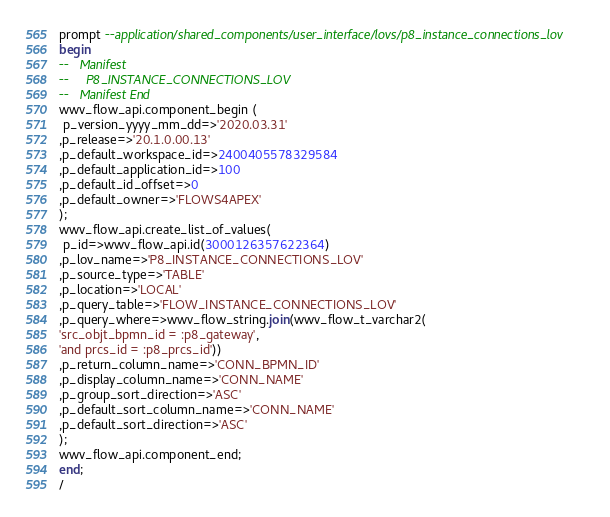<code> <loc_0><loc_0><loc_500><loc_500><_SQL_>prompt --application/shared_components/user_interface/lovs/p8_instance_connections_lov
begin
--   Manifest
--     P8_INSTANCE_CONNECTIONS_LOV
--   Manifest End
wwv_flow_api.component_begin (
 p_version_yyyy_mm_dd=>'2020.03.31'
,p_release=>'20.1.0.00.13'
,p_default_workspace_id=>2400405578329584
,p_default_application_id=>100
,p_default_id_offset=>0
,p_default_owner=>'FLOWS4APEX'
);
wwv_flow_api.create_list_of_values(
 p_id=>wwv_flow_api.id(3000126357622364)
,p_lov_name=>'P8_INSTANCE_CONNECTIONS_LOV'
,p_source_type=>'TABLE'
,p_location=>'LOCAL'
,p_query_table=>'FLOW_INSTANCE_CONNECTIONS_LOV'
,p_query_where=>wwv_flow_string.join(wwv_flow_t_varchar2(
'src_objt_bpmn_id = :p8_gateway',
'and prcs_id = :p8_prcs_id'))
,p_return_column_name=>'CONN_BPMN_ID'
,p_display_column_name=>'CONN_NAME'
,p_group_sort_direction=>'ASC'
,p_default_sort_column_name=>'CONN_NAME'
,p_default_sort_direction=>'ASC'
);
wwv_flow_api.component_end;
end;
/
</code> 